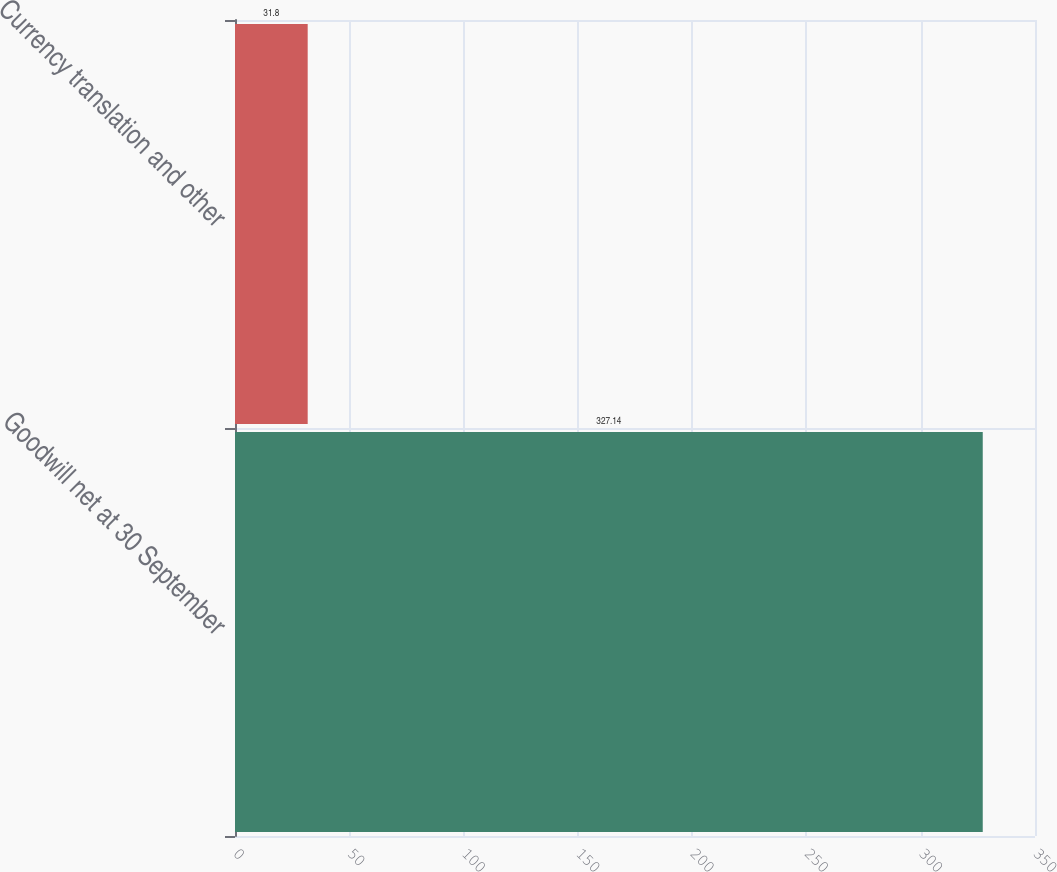Convert chart to OTSL. <chart><loc_0><loc_0><loc_500><loc_500><bar_chart><fcel>Goodwill net at 30 September<fcel>Currency translation and other<nl><fcel>327.14<fcel>31.8<nl></chart> 